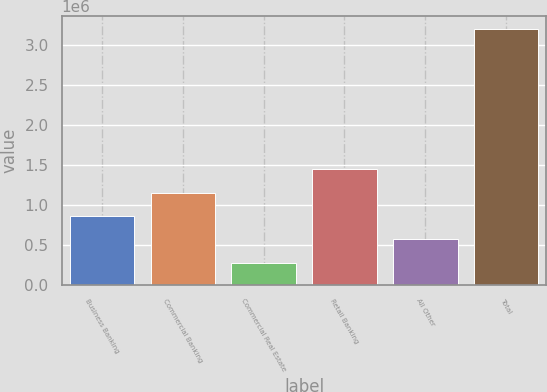<chart> <loc_0><loc_0><loc_500><loc_500><bar_chart><fcel>Business Banking<fcel>Commercial Banking<fcel>Commercial Real Estate<fcel>Retail Banking<fcel>All Other<fcel>Total<nl><fcel>859126<fcel>1.15129e+06<fcel>274799<fcel>1.44345e+06<fcel>566962<fcel>3.19643e+06<nl></chart> 